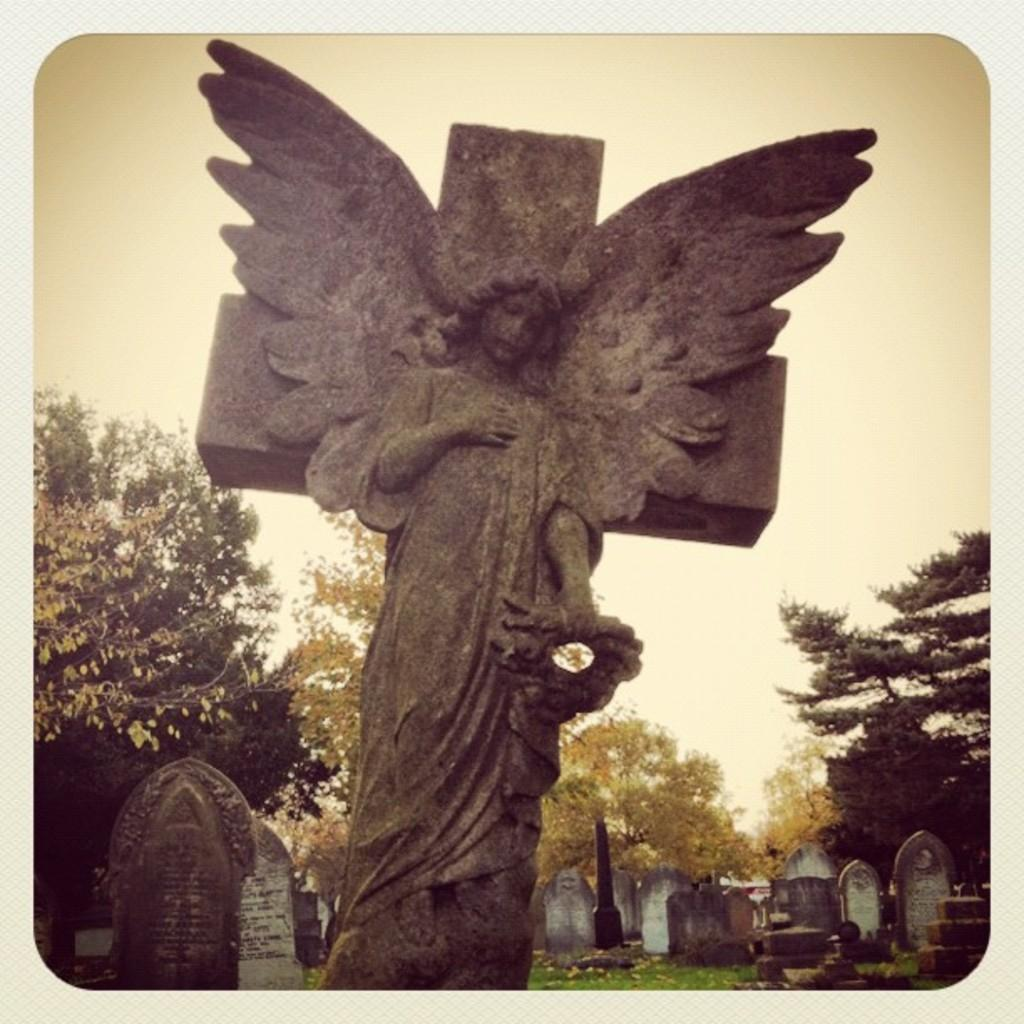What is the main subject of the image? The main subject of the image is a statue. What other elements can be seen in the image? There are tombstones, trees, and grass visible in the image. What is visible at the top of the image? The sky is visible at the top of the image. What type of lipstick is the statue wearing in the image? There is no lipstick or any indication of the statue wearing lipstick in the image. 